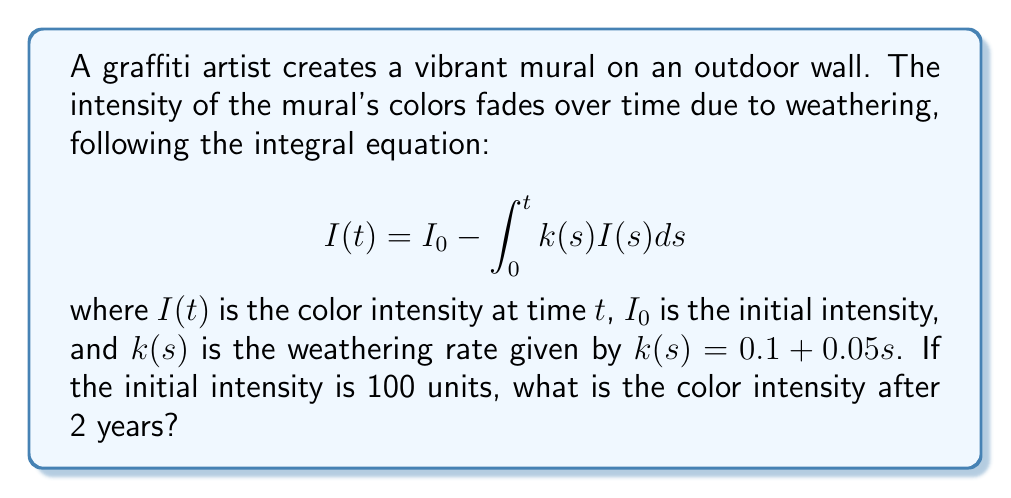Can you answer this question? 1) We start with the integral equation:
   $$I(t) = I_0 - \int_0^t k(s)I(s)ds$$

2) Substitute the given weathering rate function:
   $$I(t) = 100 - \int_0^t (0.1 + 0.05s)I(s)ds$$

3) To solve this, we can differentiate both sides with respect to $t$:
   $$\frac{dI}{dt} = -(0.1 + 0.05t)I(t)$$

4) This is now a first-order linear differential equation. We can solve it using the integrating factor method.

5) The integrating factor is:
   $$\mu(t) = e^{\int (0.1 + 0.05t)dt} = e^{0.1t + 0.025t^2}$$

6) Multiplying both sides by $\mu(t)$:
   $$\mu(t)\frac{dI}{dt} + \mu(t)(0.1 + 0.05t)I = 0$$

7) This can be rewritten as:
   $$\frac{d}{dt}[\mu(t)I] = 0$$

8) Integrating both sides:
   $$\mu(t)I = C$$

9) Substituting back the expression for $\mu(t)$:
   $$I(t) = Ce^{-0.1t - 0.025t^2}$$

10) Using the initial condition $I(0) = 100$, we find $C = 100$.

11) Therefore, the solution is:
    $$I(t) = 100e^{-0.1t - 0.025t^2}$$

12) To find the intensity after 2 years, substitute $t = 2$:
    $$I(2) = 100e^{-0.1(2) - 0.025(2^2)} = 100e^{-0.3} \approx 74.08$$
Answer: 74.08 units 